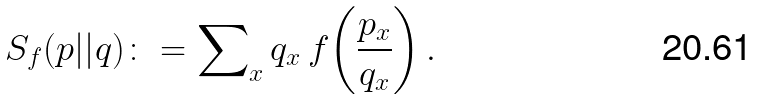<formula> <loc_0><loc_0><loc_500><loc_500>S _ { f } ( p { | | } q ) \colon = \sum \nolimits _ { x } { q _ { x } { \, } { f } { \left ( \frac { p _ { x } } { q _ { x } } \right ) } } { \, } .</formula> 